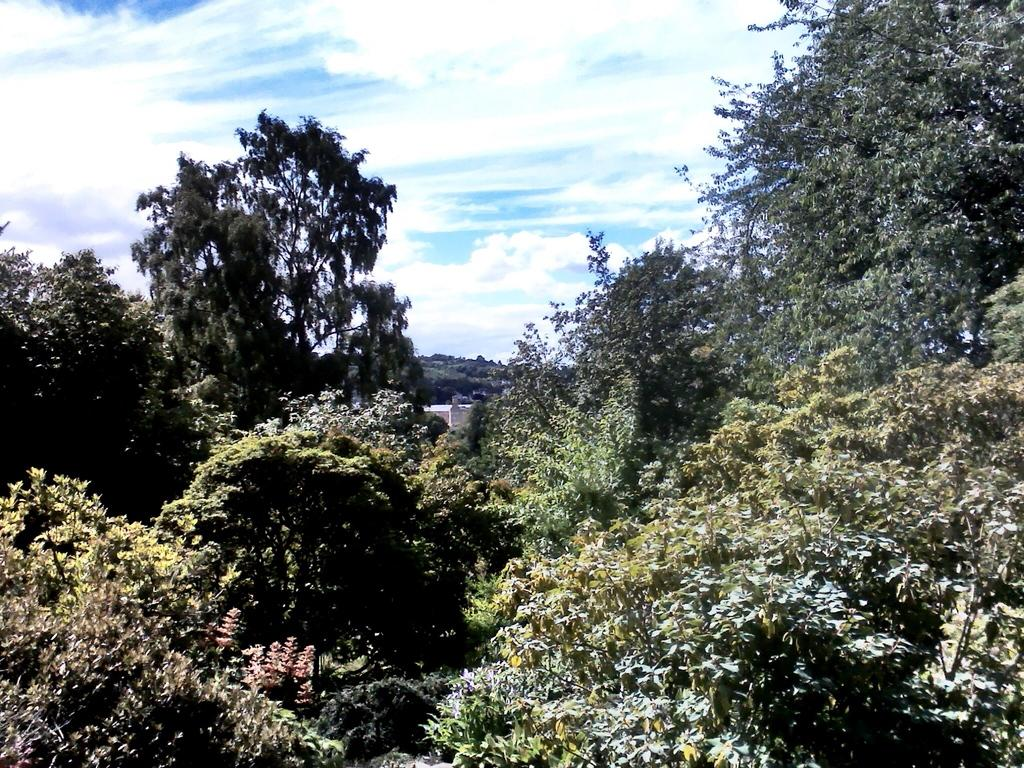What type of natural vegetation is present in the image? There are many trees in the image. What other type of plant life can be seen in the image? There are plants in the image. What is visible in the sky at the top of the image? There are clouds visible in the sky at the top of the image. What type of engine is powering the trees in the image? There is no engine present in the image, as trees are natural organisms that do not require engines for growth or movement. 